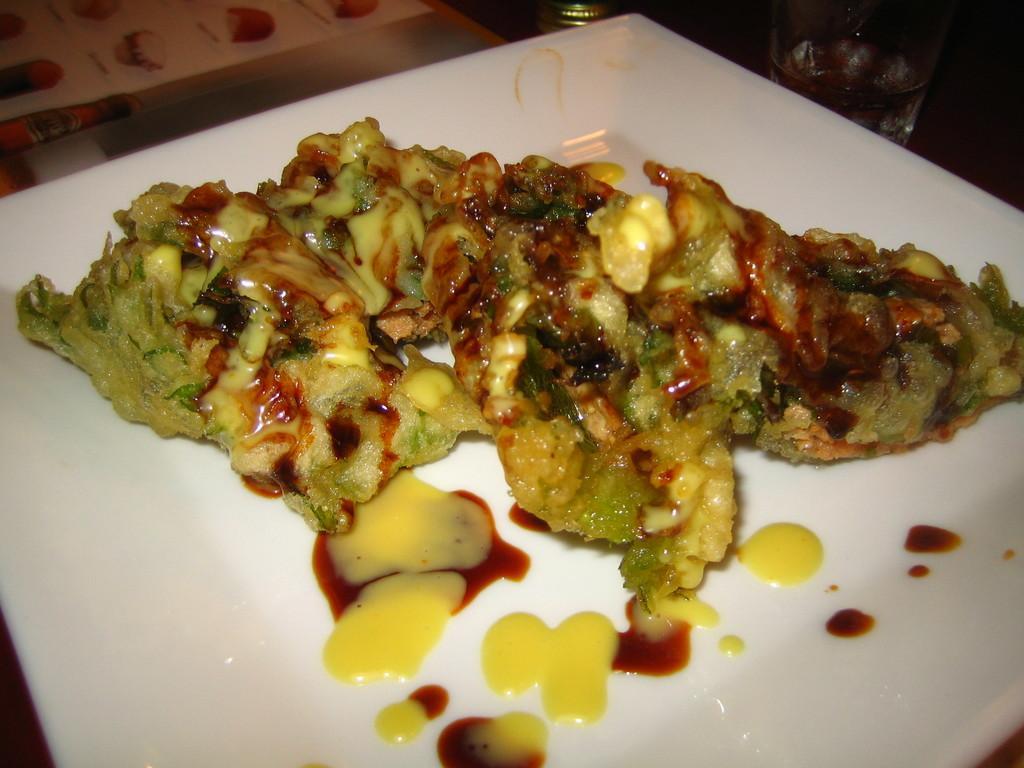Describe this image in one or two sentences. In this image, we can see some food on the white plate. 